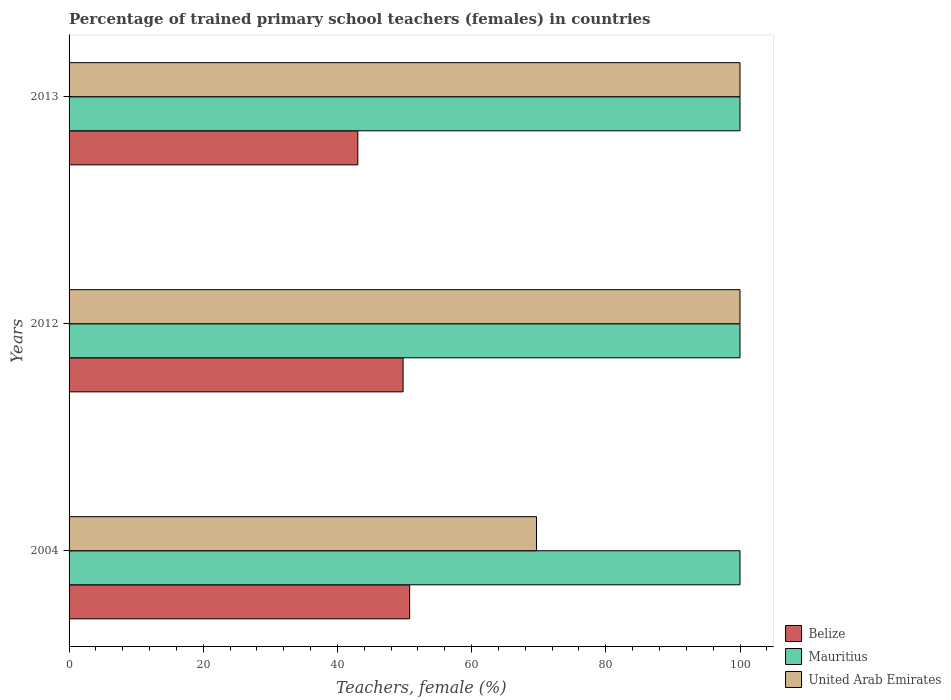Are the number of bars on each tick of the Y-axis equal?
Your answer should be compact. Yes. How many bars are there on the 3rd tick from the top?
Give a very brief answer. 3. How many bars are there on the 2nd tick from the bottom?
Your response must be concise. 3. What is the label of the 1st group of bars from the top?
Your response must be concise. 2013. In how many cases, is the number of bars for a given year not equal to the number of legend labels?
Your answer should be very brief. 0. Across all years, what is the minimum percentage of trained primary school teachers (females) in United Arab Emirates?
Ensure brevity in your answer.  69.67. In which year was the percentage of trained primary school teachers (females) in United Arab Emirates maximum?
Make the answer very short. 2012. In which year was the percentage of trained primary school teachers (females) in Mauritius minimum?
Keep it short and to the point. 2004. What is the total percentage of trained primary school teachers (females) in Belize in the graph?
Make the answer very short. 143.58. What is the difference between the percentage of trained primary school teachers (females) in United Arab Emirates in 2012 and that in 2013?
Provide a succinct answer. 0. What is the difference between the percentage of trained primary school teachers (females) in Belize in 2004 and the percentage of trained primary school teachers (females) in Mauritius in 2012?
Your answer should be compact. -49.24. What is the average percentage of trained primary school teachers (females) in Belize per year?
Make the answer very short. 47.86. In the year 2013, what is the difference between the percentage of trained primary school teachers (females) in United Arab Emirates and percentage of trained primary school teachers (females) in Mauritius?
Ensure brevity in your answer.  0. In how many years, is the percentage of trained primary school teachers (females) in Mauritius greater than 96 %?
Offer a terse response. 3. What is the ratio of the percentage of trained primary school teachers (females) in Belize in 2012 to that in 2013?
Make the answer very short. 1.16. Is the percentage of trained primary school teachers (females) in Belize in 2004 less than that in 2012?
Give a very brief answer. No. Is the difference between the percentage of trained primary school teachers (females) in United Arab Emirates in 2012 and 2013 greater than the difference between the percentage of trained primary school teachers (females) in Mauritius in 2012 and 2013?
Offer a very short reply. No. What is the difference between the highest and the second highest percentage of trained primary school teachers (females) in Belize?
Provide a succinct answer. 0.98. What is the difference between the highest and the lowest percentage of trained primary school teachers (females) in Belize?
Provide a short and direct response. 7.72. In how many years, is the percentage of trained primary school teachers (females) in United Arab Emirates greater than the average percentage of trained primary school teachers (females) in United Arab Emirates taken over all years?
Provide a succinct answer. 2. Is the sum of the percentage of trained primary school teachers (females) in Belize in 2004 and 2012 greater than the maximum percentage of trained primary school teachers (females) in Mauritius across all years?
Keep it short and to the point. Yes. What does the 2nd bar from the top in 2013 represents?
Your response must be concise. Mauritius. What does the 1st bar from the bottom in 2004 represents?
Your answer should be very brief. Belize. Is it the case that in every year, the sum of the percentage of trained primary school teachers (females) in Belize and percentage of trained primary school teachers (females) in United Arab Emirates is greater than the percentage of trained primary school teachers (females) in Mauritius?
Offer a terse response. Yes. How many bars are there?
Your answer should be very brief. 9. Are all the bars in the graph horizontal?
Offer a very short reply. Yes. How many legend labels are there?
Your answer should be very brief. 3. What is the title of the graph?
Your answer should be very brief. Percentage of trained primary school teachers (females) in countries. What is the label or title of the X-axis?
Make the answer very short. Teachers, female (%). What is the Teachers, female (%) in Belize in 2004?
Give a very brief answer. 50.76. What is the Teachers, female (%) of Mauritius in 2004?
Your answer should be very brief. 100. What is the Teachers, female (%) in United Arab Emirates in 2004?
Provide a short and direct response. 69.67. What is the Teachers, female (%) in Belize in 2012?
Offer a very short reply. 49.78. What is the Teachers, female (%) of Mauritius in 2012?
Your answer should be compact. 100. What is the Teachers, female (%) in Belize in 2013?
Provide a succinct answer. 43.04. What is the Teachers, female (%) in United Arab Emirates in 2013?
Give a very brief answer. 100. Across all years, what is the maximum Teachers, female (%) of Belize?
Make the answer very short. 50.76. Across all years, what is the maximum Teachers, female (%) of Mauritius?
Your answer should be very brief. 100. Across all years, what is the maximum Teachers, female (%) of United Arab Emirates?
Give a very brief answer. 100. Across all years, what is the minimum Teachers, female (%) of Belize?
Give a very brief answer. 43.04. Across all years, what is the minimum Teachers, female (%) in Mauritius?
Ensure brevity in your answer.  100. Across all years, what is the minimum Teachers, female (%) of United Arab Emirates?
Ensure brevity in your answer.  69.67. What is the total Teachers, female (%) of Belize in the graph?
Keep it short and to the point. 143.58. What is the total Teachers, female (%) of Mauritius in the graph?
Your response must be concise. 300. What is the total Teachers, female (%) in United Arab Emirates in the graph?
Make the answer very short. 269.67. What is the difference between the Teachers, female (%) of Belize in 2004 and that in 2012?
Provide a succinct answer. 0.98. What is the difference between the Teachers, female (%) in Mauritius in 2004 and that in 2012?
Your answer should be very brief. 0. What is the difference between the Teachers, female (%) in United Arab Emirates in 2004 and that in 2012?
Your answer should be very brief. -30.33. What is the difference between the Teachers, female (%) of Belize in 2004 and that in 2013?
Your answer should be compact. 7.72. What is the difference between the Teachers, female (%) of United Arab Emirates in 2004 and that in 2013?
Keep it short and to the point. -30.33. What is the difference between the Teachers, female (%) of Belize in 2012 and that in 2013?
Your answer should be very brief. 6.75. What is the difference between the Teachers, female (%) of United Arab Emirates in 2012 and that in 2013?
Provide a succinct answer. 0. What is the difference between the Teachers, female (%) in Belize in 2004 and the Teachers, female (%) in Mauritius in 2012?
Your answer should be compact. -49.24. What is the difference between the Teachers, female (%) in Belize in 2004 and the Teachers, female (%) in United Arab Emirates in 2012?
Offer a very short reply. -49.24. What is the difference between the Teachers, female (%) in Mauritius in 2004 and the Teachers, female (%) in United Arab Emirates in 2012?
Your response must be concise. 0. What is the difference between the Teachers, female (%) in Belize in 2004 and the Teachers, female (%) in Mauritius in 2013?
Your response must be concise. -49.24. What is the difference between the Teachers, female (%) in Belize in 2004 and the Teachers, female (%) in United Arab Emirates in 2013?
Your answer should be compact. -49.24. What is the difference between the Teachers, female (%) in Belize in 2012 and the Teachers, female (%) in Mauritius in 2013?
Your response must be concise. -50.22. What is the difference between the Teachers, female (%) of Belize in 2012 and the Teachers, female (%) of United Arab Emirates in 2013?
Your answer should be very brief. -50.22. What is the average Teachers, female (%) in Belize per year?
Make the answer very short. 47.86. What is the average Teachers, female (%) of Mauritius per year?
Keep it short and to the point. 100. What is the average Teachers, female (%) in United Arab Emirates per year?
Give a very brief answer. 89.89. In the year 2004, what is the difference between the Teachers, female (%) in Belize and Teachers, female (%) in Mauritius?
Offer a terse response. -49.24. In the year 2004, what is the difference between the Teachers, female (%) of Belize and Teachers, female (%) of United Arab Emirates?
Keep it short and to the point. -18.91. In the year 2004, what is the difference between the Teachers, female (%) in Mauritius and Teachers, female (%) in United Arab Emirates?
Give a very brief answer. 30.33. In the year 2012, what is the difference between the Teachers, female (%) of Belize and Teachers, female (%) of Mauritius?
Your response must be concise. -50.22. In the year 2012, what is the difference between the Teachers, female (%) of Belize and Teachers, female (%) of United Arab Emirates?
Your response must be concise. -50.22. In the year 2013, what is the difference between the Teachers, female (%) of Belize and Teachers, female (%) of Mauritius?
Ensure brevity in your answer.  -56.96. In the year 2013, what is the difference between the Teachers, female (%) in Belize and Teachers, female (%) in United Arab Emirates?
Make the answer very short. -56.96. What is the ratio of the Teachers, female (%) in Belize in 2004 to that in 2012?
Offer a very short reply. 1.02. What is the ratio of the Teachers, female (%) in United Arab Emirates in 2004 to that in 2012?
Your answer should be compact. 0.7. What is the ratio of the Teachers, female (%) in Belize in 2004 to that in 2013?
Your answer should be very brief. 1.18. What is the ratio of the Teachers, female (%) of Mauritius in 2004 to that in 2013?
Your response must be concise. 1. What is the ratio of the Teachers, female (%) in United Arab Emirates in 2004 to that in 2013?
Your answer should be very brief. 0.7. What is the ratio of the Teachers, female (%) of Belize in 2012 to that in 2013?
Your response must be concise. 1.16. What is the difference between the highest and the second highest Teachers, female (%) of Belize?
Keep it short and to the point. 0.98. What is the difference between the highest and the second highest Teachers, female (%) of Mauritius?
Make the answer very short. 0. What is the difference between the highest and the second highest Teachers, female (%) in United Arab Emirates?
Make the answer very short. 0. What is the difference between the highest and the lowest Teachers, female (%) in Belize?
Give a very brief answer. 7.72. What is the difference between the highest and the lowest Teachers, female (%) in Mauritius?
Ensure brevity in your answer.  0. What is the difference between the highest and the lowest Teachers, female (%) of United Arab Emirates?
Ensure brevity in your answer.  30.33. 